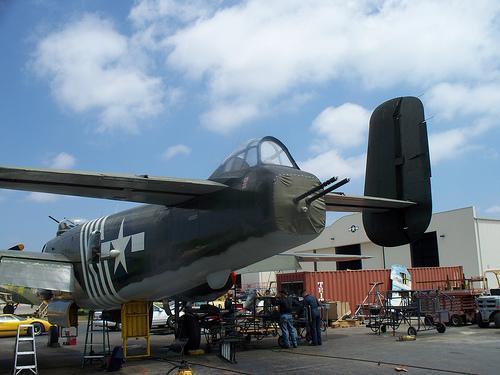How many airplanes?
Give a very brief answer. 1. 